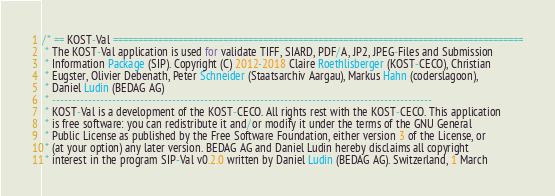<code> <loc_0><loc_0><loc_500><loc_500><_Java_>/* == KOST-Val ==================================================================================
 * The KOST-Val application is used for validate TIFF, SIARD, PDF/A, JP2, JPEG-Files and Submission
 * Information Package (SIP). Copyright (C) 2012-2018 Claire Roethlisberger (KOST-CECO), Christian
 * Eugster, Olivier Debenath, Peter Schneider (Staatsarchiv Aargau), Markus Hahn (coderslagoon),
 * Daniel Ludin (BEDAG AG)
 * -----------------------------------------------------------------------------------------------
 * KOST-Val is a development of the KOST-CECO. All rights rest with the KOST-CECO. This application
 * is free software: you can redistribute it and/or modify it under the terms of the GNU General
 * Public License as published by the Free Software Foundation, either version 3 of the License, or
 * (at your option) any later version. BEDAG AG and Daniel Ludin hereby disclaims all copyright
 * interest in the program SIP-Val v0.2.0 written by Daniel Ludin (BEDAG AG). Switzerland, 1 March</code> 